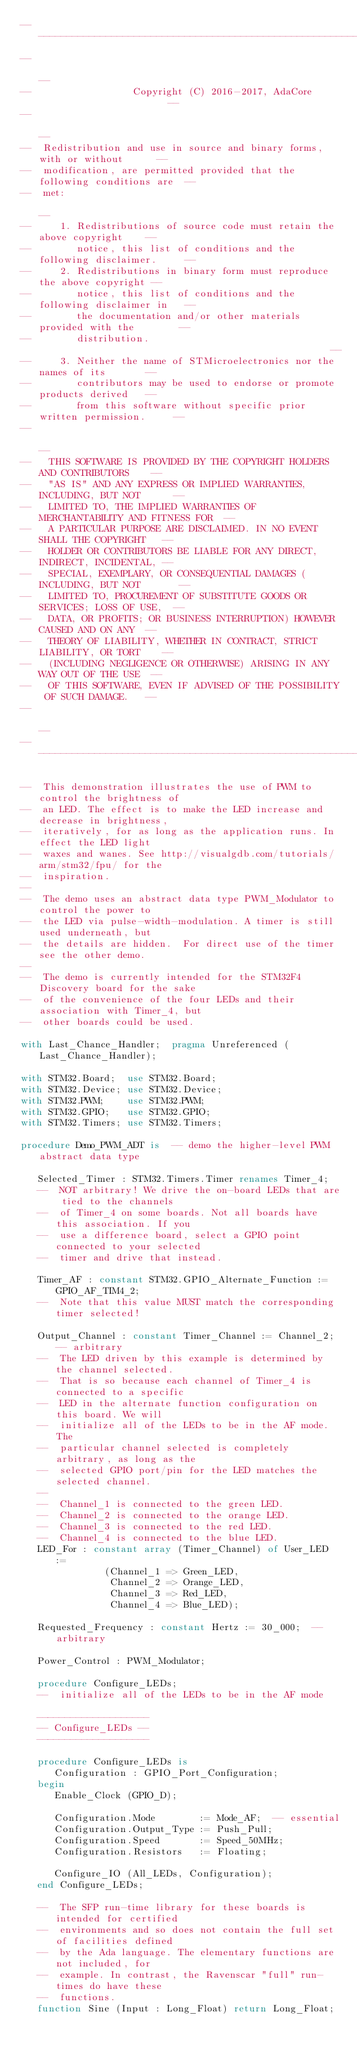<code> <loc_0><loc_0><loc_500><loc_500><_Ada_>------------------------------------------------------------------------------
--                                                                          --
--                  Copyright (C) 2016-2017, AdaCore                        --
--                                                                          --
--  Redistribution and use in source and binary forms, with or without      --
--  modification, are permitted provided that the following conditions are  --
--  met:                                                                    --
--     1. Redistributions of source code must retain the above copyright    --
--        notice, this list of conditions and the following disclaimer.     --
--     2. Redistributions in binary form must reproduce the above copyright --
--        notice, this list of conditions and the following disclaimer in   --
--        the documentation and/or other materials provided with the        --
--        distribution.                                                     --
--     3. Neither the name of STMicroelectronics nor the names of its       --
--        contributors may be used to endorse or promote products derived   --
--        from this software without specific prior written permission.     --
--                                                                          --
--   THIS SOFTWARE IS PROVIDED BY THE COPYRIGHT HOLDERS AND CONTRIBUTORS    --
--   "AS IS" AND ANY EXPRESS OR IMPLIED WARRANTIES, INCLUDING, BUT NOT      --
--   LIMITED TO, THE IMPLIED WARRANTIES OF MERCHANTABILITY AND FITNESS FOR  --
--   A PARTICULAR PURPOSE ARE DISCLAIMED. IN NO EVENT SHALL THE COPYRIGHT   --
--   HOLDER OR CONTRIBUTORS BE LIABLE FOR ANY DIRECT, INDIRECT, INCIDENTAL, --
--   SPECIAL, EXEMPLARY, OR CONSEQUENTIAL DAMAGES (INCLUDING, BUT NOT       --
--   LIMITED TO, PROCUREMENT OF SUBSTITUTE GOODS OR SERVICES; LOSS OF USE,  --
--   DATA, OR PROFITS; OR BUSINESS INTERRUPTION) HOWEVER CAUSED AND ON ANY  --
--   THEORY OF LIABILITY, WHETHER IN CONTRACT, STRICT LIABILITY, OR TORT    --
--   (INCLUDING NEGLIGENCE OR OTHERWISE) ARISING IN ANY WAY OUT OF THE USE  --
--   OF THIS SOFTWARE, EVEN IF ADVISED OF THE POSSIBILITY OF SUCH DAMAGE.   --
--                                                                          --
------------------------------------------------------------------------------

--  This demonstration illustrates the use of PWM to control the brightness of
--  an LED. The effect is to make the LED increase and decrease in brightness,
--  iteratively, for as long as the application runs. In effect the LED light
--  waxes and wanes. See http://visualgdb.com/tutorials/arm/stm32/fpu/ for the
--  inspiration.
--
--  The demo uses an abstract data type PWM_Modulator to control the power to
--  the LED via pulse-width-modulation. A timer is still used underneath, but
--  the details are hidden.  For direct use of the timer see the other demo.
--
--  The demo is currently intended for the STM32F4 Discovery board for the sake
--  of the convenience of the four LEDs and their association with Timer_4, but
--  other boards could be used.

with Last_Chance_Handler;  pragma Unreferenced (Last_Chance_Handler);

with STM32.Board;  use STM32.Board;
with STM32.Device; use STM32.Device;
with STM32.PWM;    use STM32.PWM;
with STM32.GPIO;   use STM32.GPIO;
with STM32.Timers; use STM32.Timers;

procedure Demo_PWM_ADT is  -- demo the higher-level PWM abstract data type

   Selected_Timer : STM32.Timers.Timer renames Timer_4;
   --  NOT arbitrary! We drive the on-board LEDs that are tied to the channels
   --  of Timer_4 on some boards. Not all boards have this association. If you
   --  use a difference board, select a GPIO point connected to your selected
   --  timer and drive that instead.

   Timer_AF : constant STM32.GPIO_Alternate_Function := GPIO_AF_TIM4_2;
   --  Note that this value MUST match the corresponding timer selected!

   Output_Channel : constant Timer_Channel := Channel_2; -- arbitrary
   --  The LED driven by this example is determined by the channel selected.
   --  That is so because each channel of Timer_4 is connected to a specific
   --  LED in the alternate function configuration on this board. We will
   --  initialize all of the LEDs to be in the AF mode. The
   --  particular channel selected is completely arbitrary, as long as the
   --  selected GPIO port/pin for the LED matches the selected channel.
   --
   --  Channel_1 is connected to the green LED.
   --  Channel_2 is connected to the orange LED.
   --  Channel_3 is connected to the red LED.
   --  Channel_4 is connected to the blue LED.
   LED_For : constant array (Timer_Channel) of User_LED :=
               (Channel_1 => Green_LED,
                Channel_2 => Orange_LED,
                Channel_3 => Red_LED,
                Channel_4 => Blue_LED);

   Requested_Frequency : constant Hertz := 30_000;  -- arbitrary

   Power_Control : PWM_Modulator;

   procedure Configure_LEDs;
   --  initialize all of the LEDs to be in the AF mode

   --------------------
   -- Configure_LEDs --
   --------------------

   procedure Configure_LEDs is
      Configuration : GPIO_Port_Configuration;
   begin
      Enable_Clock (GPIO_D);

      Configuration.Mode        := Mode_AF;  -- essential
      Configuration.Output_Type := Push_Pull;
      Configuration.Speed       := Speed_50MHz;
      Configuration.Resistors   := Floating;

      Configure_IO (All_LEDs, Configuration);
   end Configure_LEDs;

   --  The SFP run-time library for these boards is intended for certified
   --  environments and so does not contain the full set of facilities defined
   --  by the Ada language. The elementary functions are not included, for
   --  example. In contrast, the Ravenscar "full" run-times do have these
   --  functions.
   function Sine (Input : Long_Float) return Long_Float;
</code> 